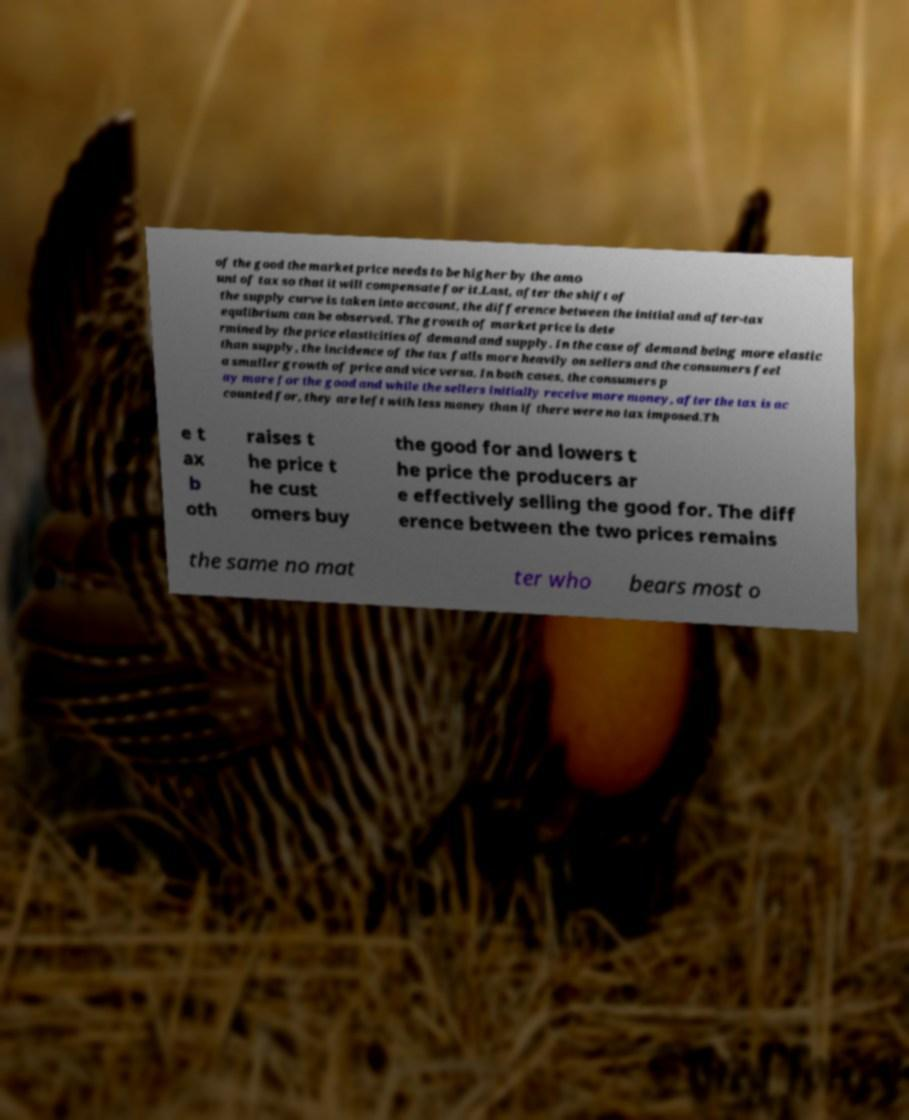There's text embedded in this image that I need extracted. Can you transcribe it verbatim? of the good the market price needs to be higher by the amo unt of tax so that it will compensate for it.Last, after the shift of the supply curve is taken into account, the difference between the initial and after-tax equlibrium can be observed. The growth of market price is dete rmined by the price elasticities of demand and supply. In the case of demand being more elastic than supply, the incidence of the tax falls more heavily on sellers and the consumers feel a smaller growth of price and vice versa. In both cases, the consumers p ay more for the good and while the sellers initially receive more money, after the tax is ac counted for, they are left with less money than if there were no tax imposed.Th e t ax b oth raises t he price t he cust omers buy the good for and lowers t he price the producers ar e effectively selling the good for. The diff erence between the two prices remains the same no mat ter who bears most o 